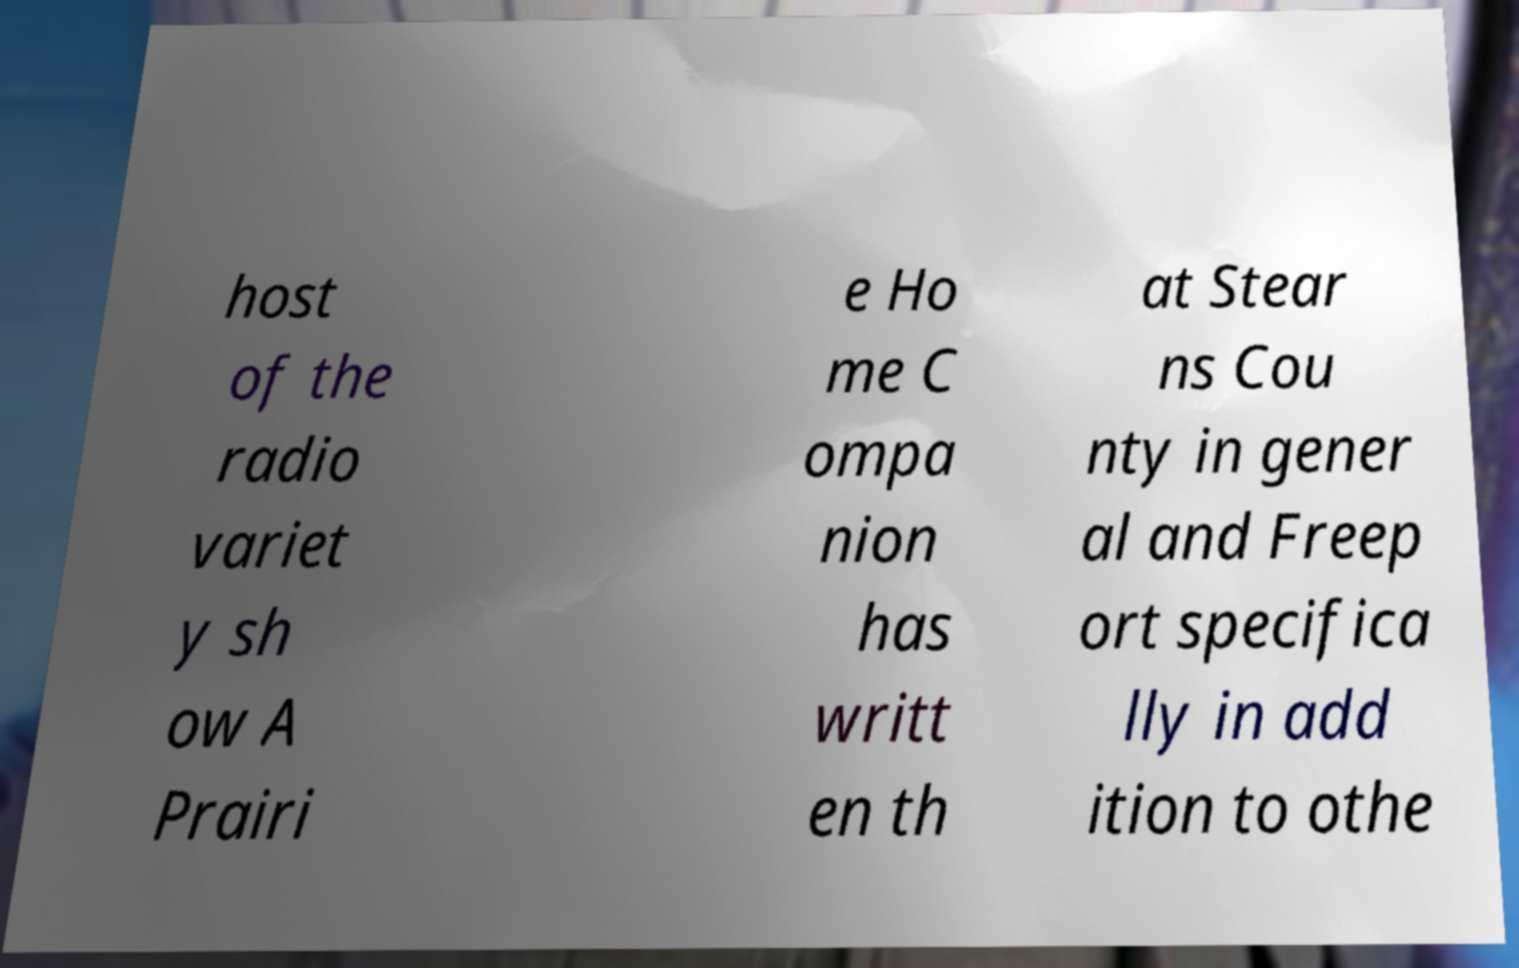Can you read and provide the text displayed in the image?This photo seems to have some interesting text. Can you extract and type it out for me? host of the radio variet y sh ow A Prairi e Ho me C ompa nion has writt en th at Stear ns Cou nty in gener al and Freep ort specifica lly in add ition to othe 